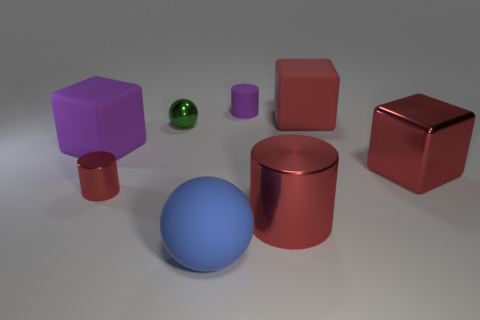Subtract all purple cylinders. How many cylinders are left? 2 Subtract all red shiny blocks. How many blocks are left? 2 Subtract 2 cubes. How many cubes are left? 1 Subtract 0 blue cylinders. How many objects are left? 8 Subtract all spheres. How many objects are left? 6 Subtract all purple cubes. Subtract all purple cylinders. How many cubes are left? 2 Subtract all yellow cylinders. How many gray balls are left? 0 Subtract all small purple matte cylinders. Subtract all green metal objects. How many objects are left? 6 Add 5 big red metallic blocks. How many big red metallic blocks are left? 6 Add 1 tiny red metal objects. How many tiny red metal objects exist? 2 